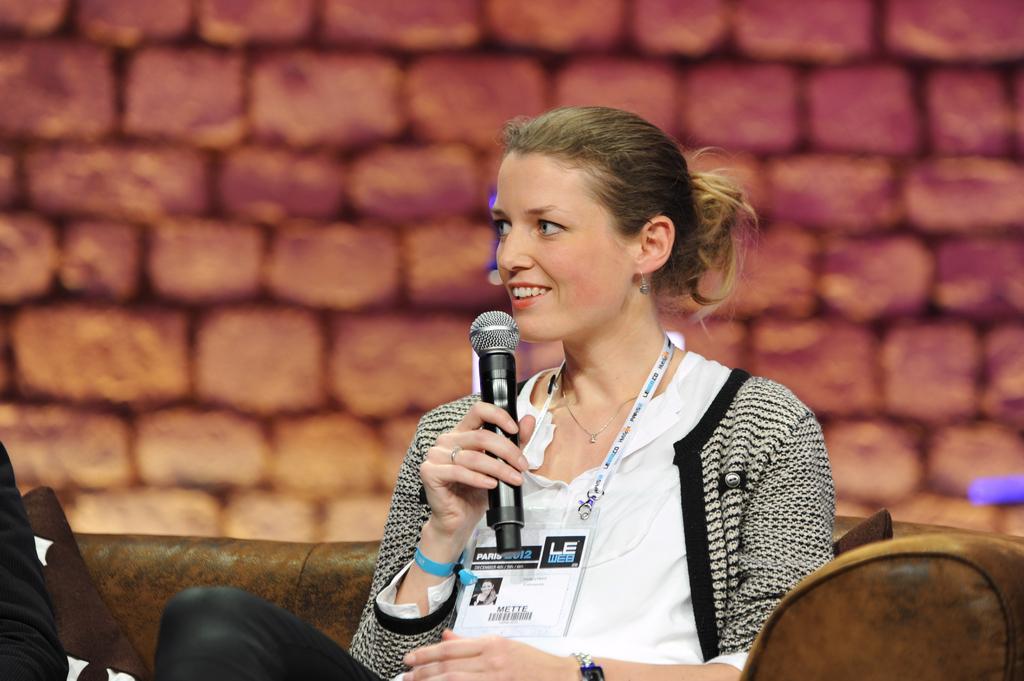In one or two sentences, can you explain what this image depicts? In the image we can see there is a woman who is sitting and she is holding a mike in her hand. 